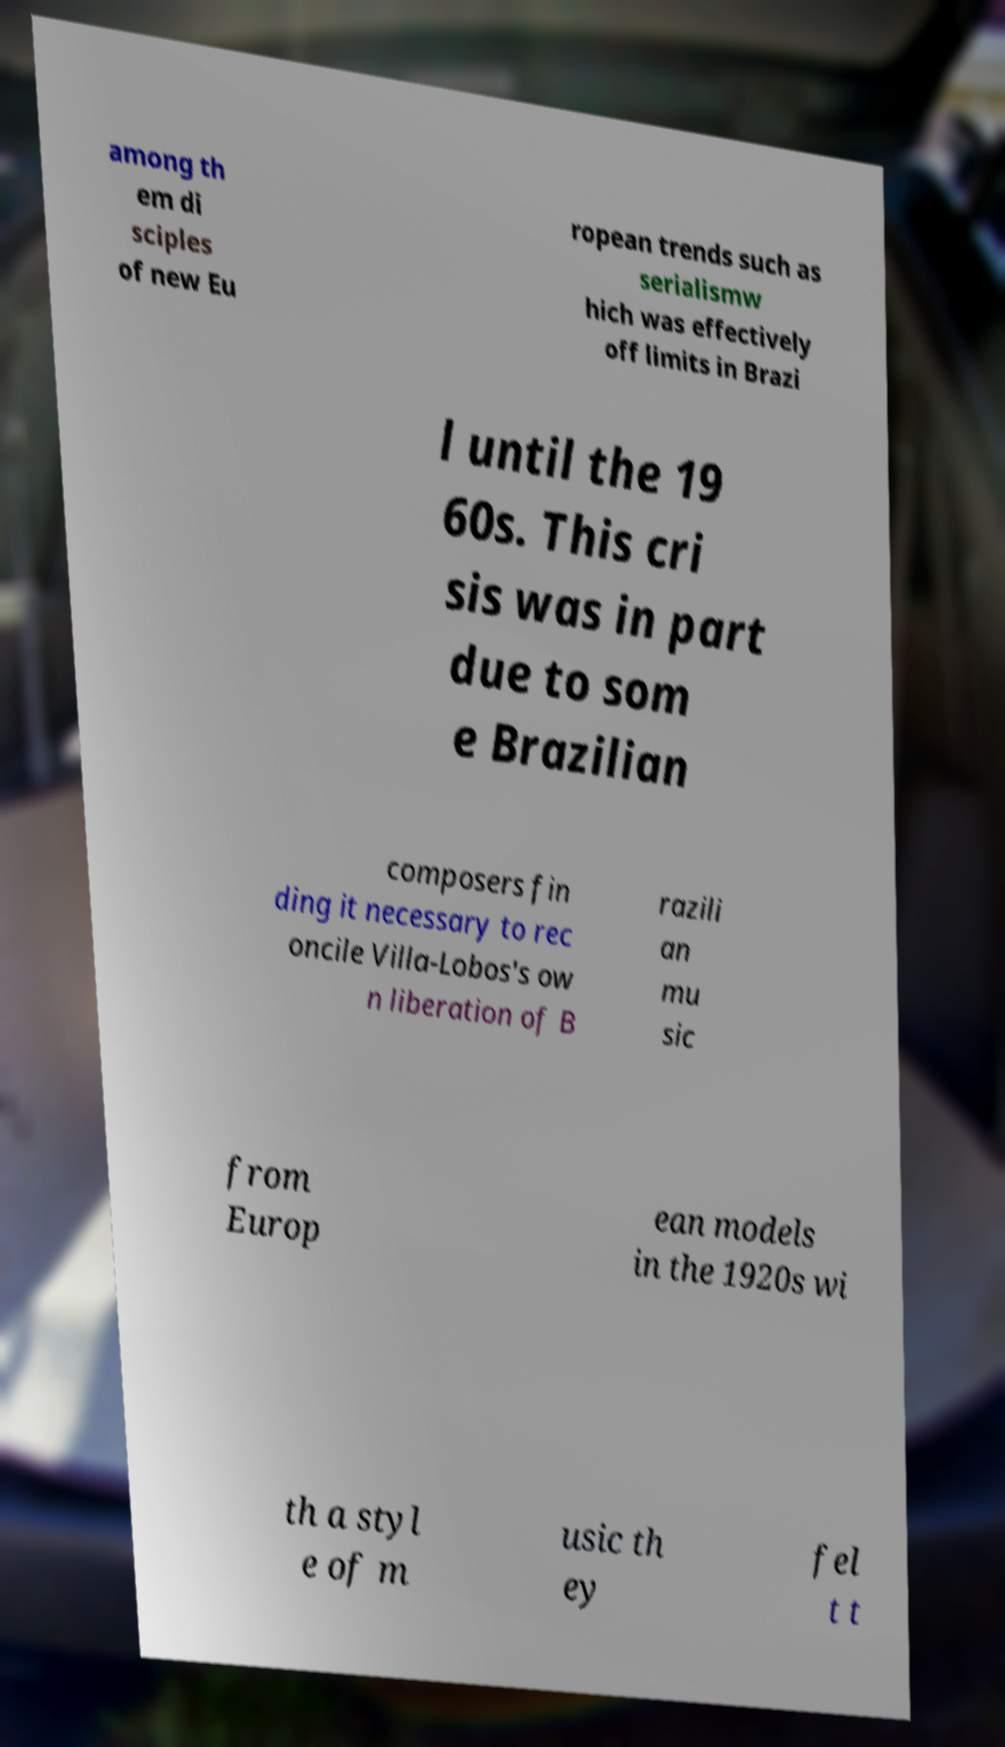Could you extract and type out the text from this image? among th em di sciples of new Eu ropean trends such as serialismw hich was effectively off limits in Brazi l until the 19 60s. This cri sis was in part due to som e Brazilian composers fin ding it necessary to rec oncile Villa-Lobos's ow n liberation of B razili an mu sic from Europ ean models in the 1920s wi th a styl e of m usic th ey fel t t 